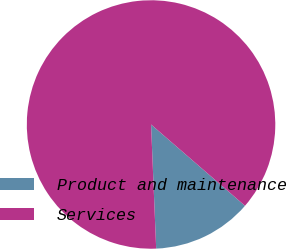Convert chart to OTSL. <chart><loc_0><loc_0><loc_500><loc_500><pie_chart><fcel>Product and maintenance<fcel>Services<nl><fcel>12.99%<fcel>87.01%<nl></chart> 